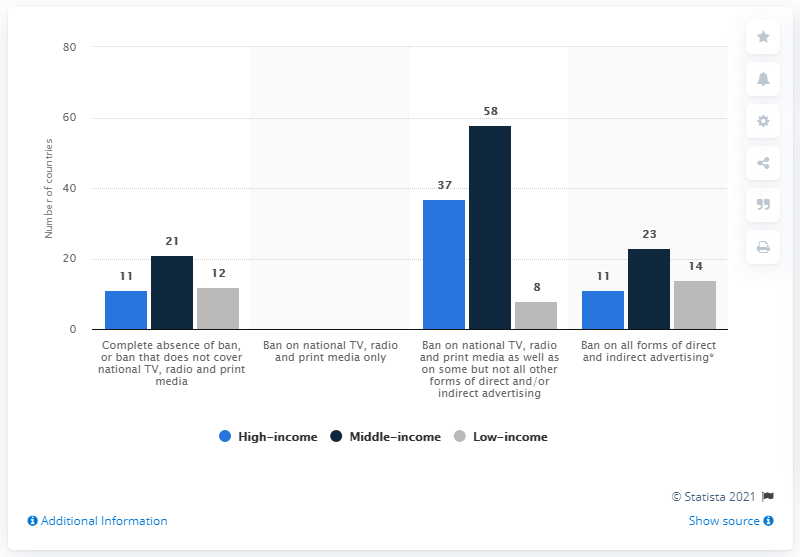Point out several critical features in this image. In 2018, a total of 11 high-income countries banned all forms of direct and indirect advertising. There are four bars above the value of 20. The value of the highest dark blue bar is 58. 